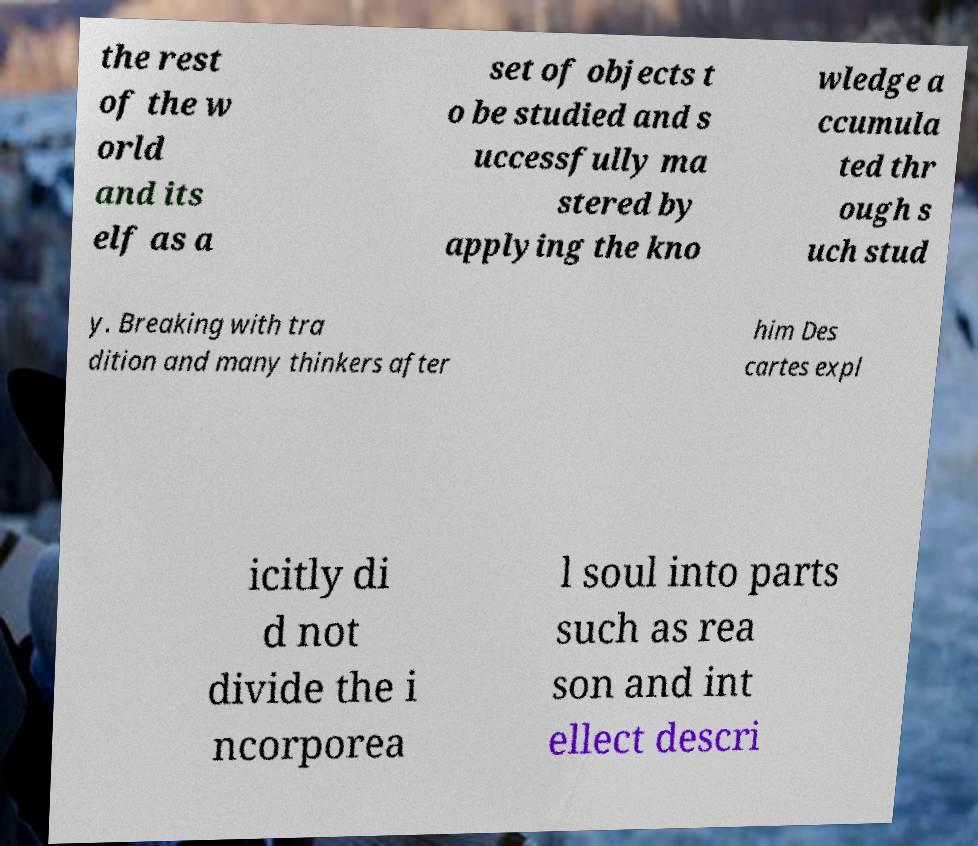I need the written content from this picture converted into text. Can you do that? the rest of the w orld and its elf as a set of objects t o be studied and s uccessfully ma stered by applying the kno wledge a ccumula ted thr ough s uch stud y. Breaking with tra dition and many thinkers after him Des cartes expl icitly di d not divide the i ncorporea l soul into parts such as rea son and int ellect descri 